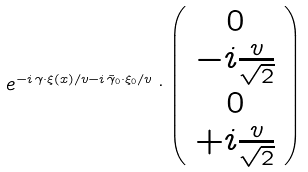Convert formula to latex. <formula><loc_0><loc_0><loc_500><loc_500>e ^ { - i \, \gamma \cdot \xi ( x ) / v - i \, \tilde { \gamma } _ { 0 } \cdot \xi _ { 0 } / v } \cdot \left ( \begin{array} { c } 0 \\ - i \frac { v } { \sqrt { 2 } } \\ 0 \\ + i \frac { v } { \sqrt { 2 } } \\ \end{array} \right )</formula> 